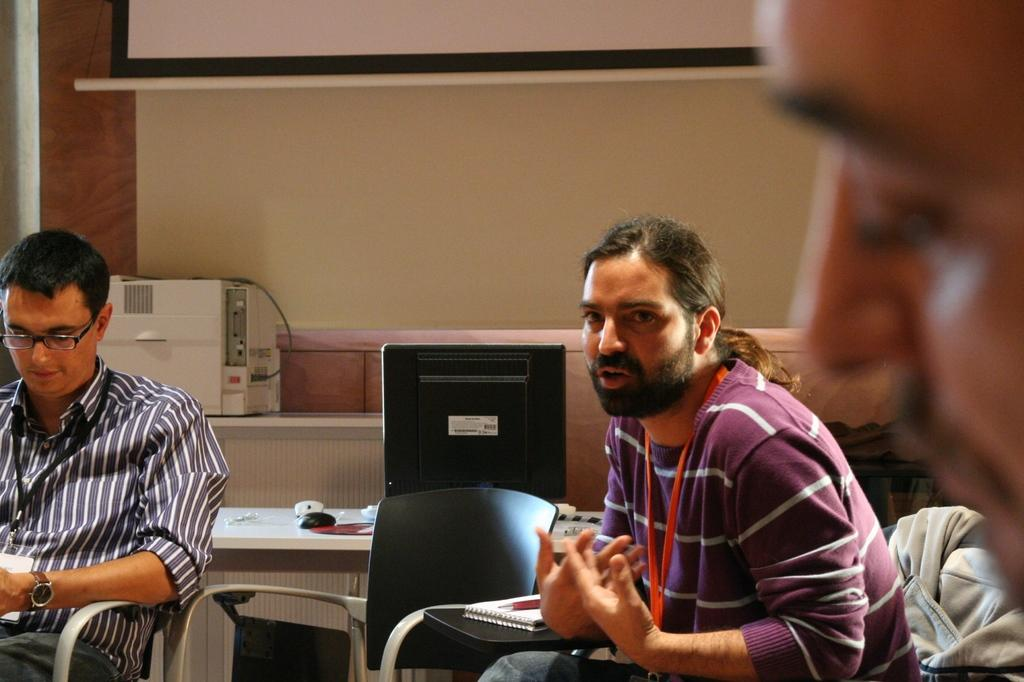How many persons are visible in the image? There are two persons sitting in chairs in the image. What can be seen in the background of the image? In the background, there is a mouse, a monitor, another chair, a table, a screen, a jacket, and another person. What might the persons be using the monitor for? It is not clear from the image what the persons are using the monitor for, but it could be for work or leisure activities. What is the position of the jacket in the image? The jacket is in the background of the image, hanging on a chair or hook. What type of note is the mouse taking in the image? There is no mouse taking notes in the image; it is a small animal in the background. What action is the temper performing in the image? There is no temper present in the image, and therefore no action can be attributed to it. 